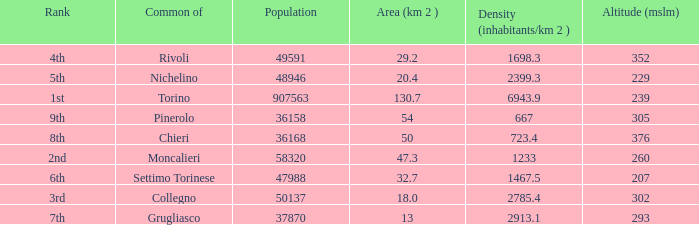What is the name of the 9th ranked common? Pinerolo. 